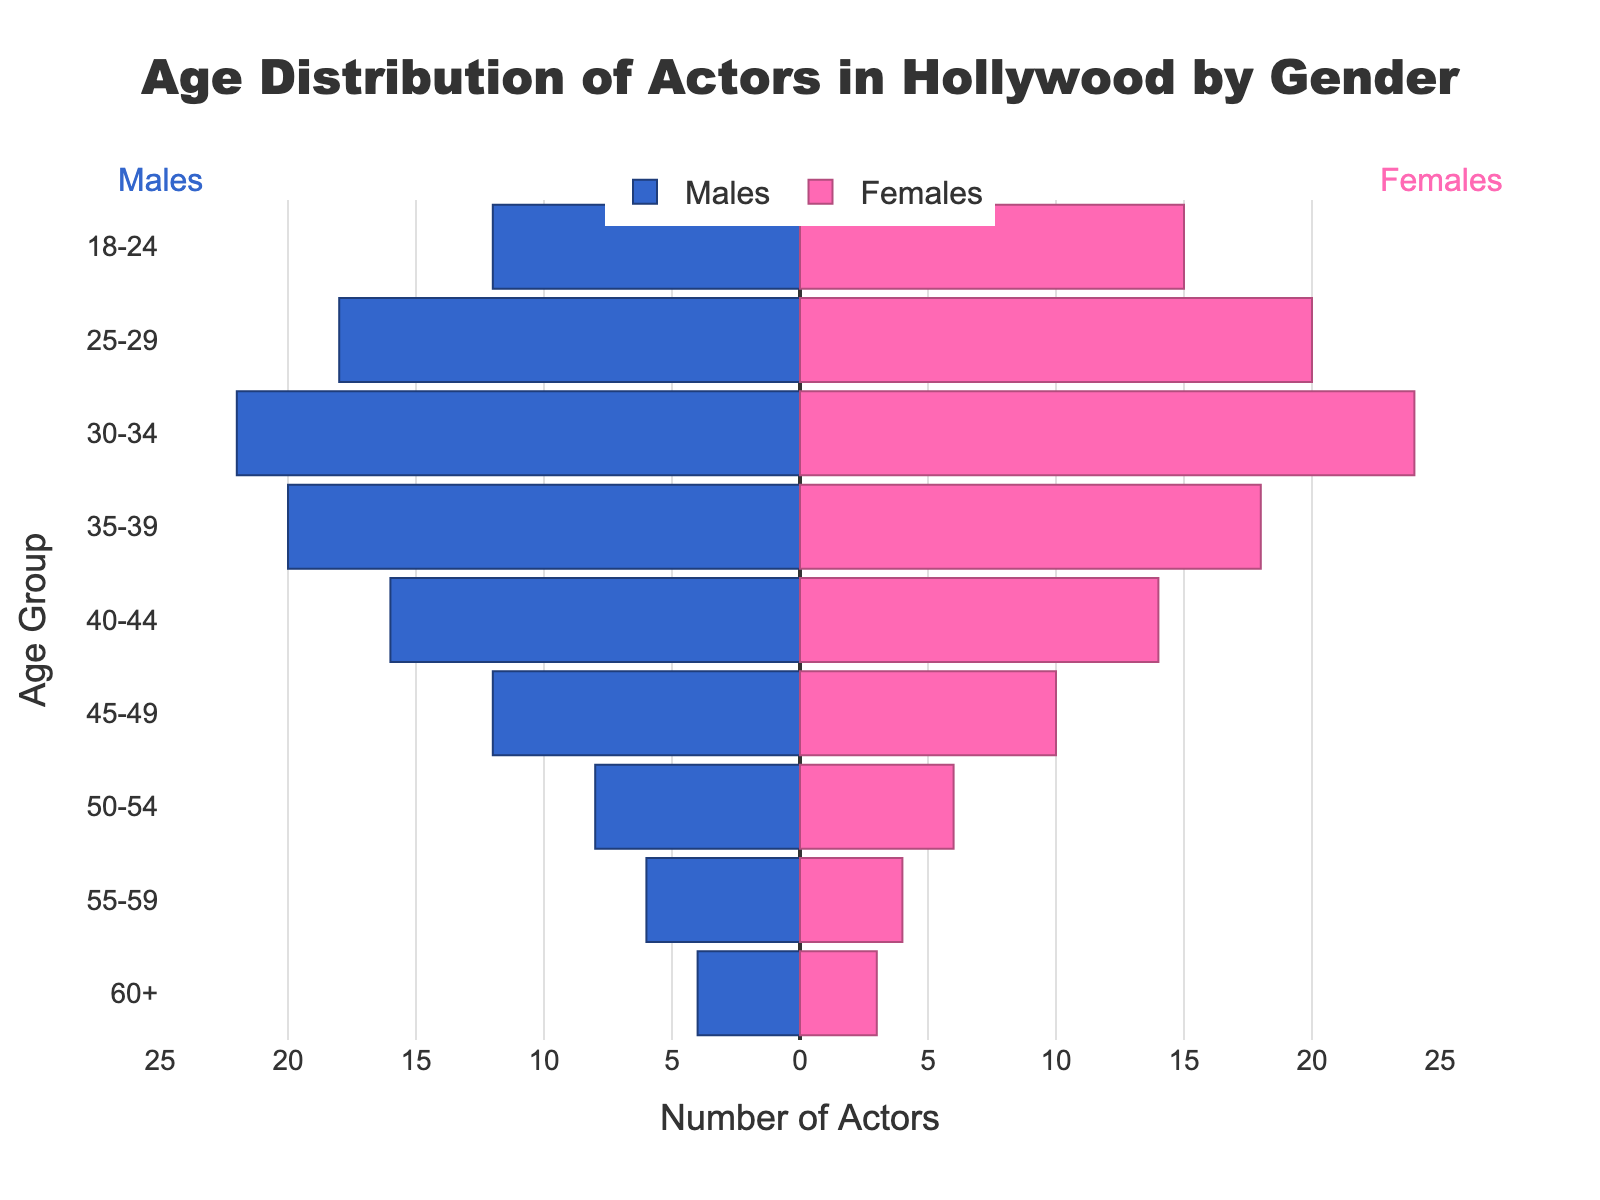What age group has the highest number of male actors? To find the age group with the highest number of male actors, look for the bar with the greatest length on the male side (blue bars). The age group 30-34 has the longest blue bar representing 22 actors.
Answer: 30-34 What is the total number of female actors in the 25-29 and 30-34 age groups combined? Sum the number of female actors in the 25-29 and 30-34 age groups: 20 (25-29) + 24 (30-34) = 44.
Answer: 44 Are there more male or female actors in the 35-39 age group? Compare the lengths of the bars for males and females in the 35-39 age group: there are 20 male actors and 18 female actors. The number of males is larger.
Answer: Males What is the age group with the lowest overall representation of actors? Add the males and females for each age group to find which has the lowest total. The age group 60+ has the fewest actors combined: 4 males + 3 females = 7.
Answer: 60+ What is the percentage of male actors in the 30-34 age group out of the total actors in this age group? The total number of actors in the 30-34 age group is 22 males + 24 females = 46. The percentage of males is (22/46) * 100 ≈ 47.83%.
Answer: 47.83% How does the number of female actors in the 45-49 age group compare to those in the 18-24 age group? For the 45-49 age group, there are 10 female actors, and for the 18-24 age group, there are 15 female actors. Thus, there are 5 fewer female actors in the 45-49 age group.
Answer: 5 fewer What is the difference between the number of male and female actors in the 25-29 age group? Subtract the number of male actors from female actors in the 25-29 age group: 20 - 18 = 2. This means there are 2 more female actors.
Answer: 2 more females Which age group shows the most balanced representation of males and females? The 35-39 age group has 20 male and 18 female actors, showing the smallest difference of 2. This is the most balanced representation in terms of gender.
Answer: 35-39 